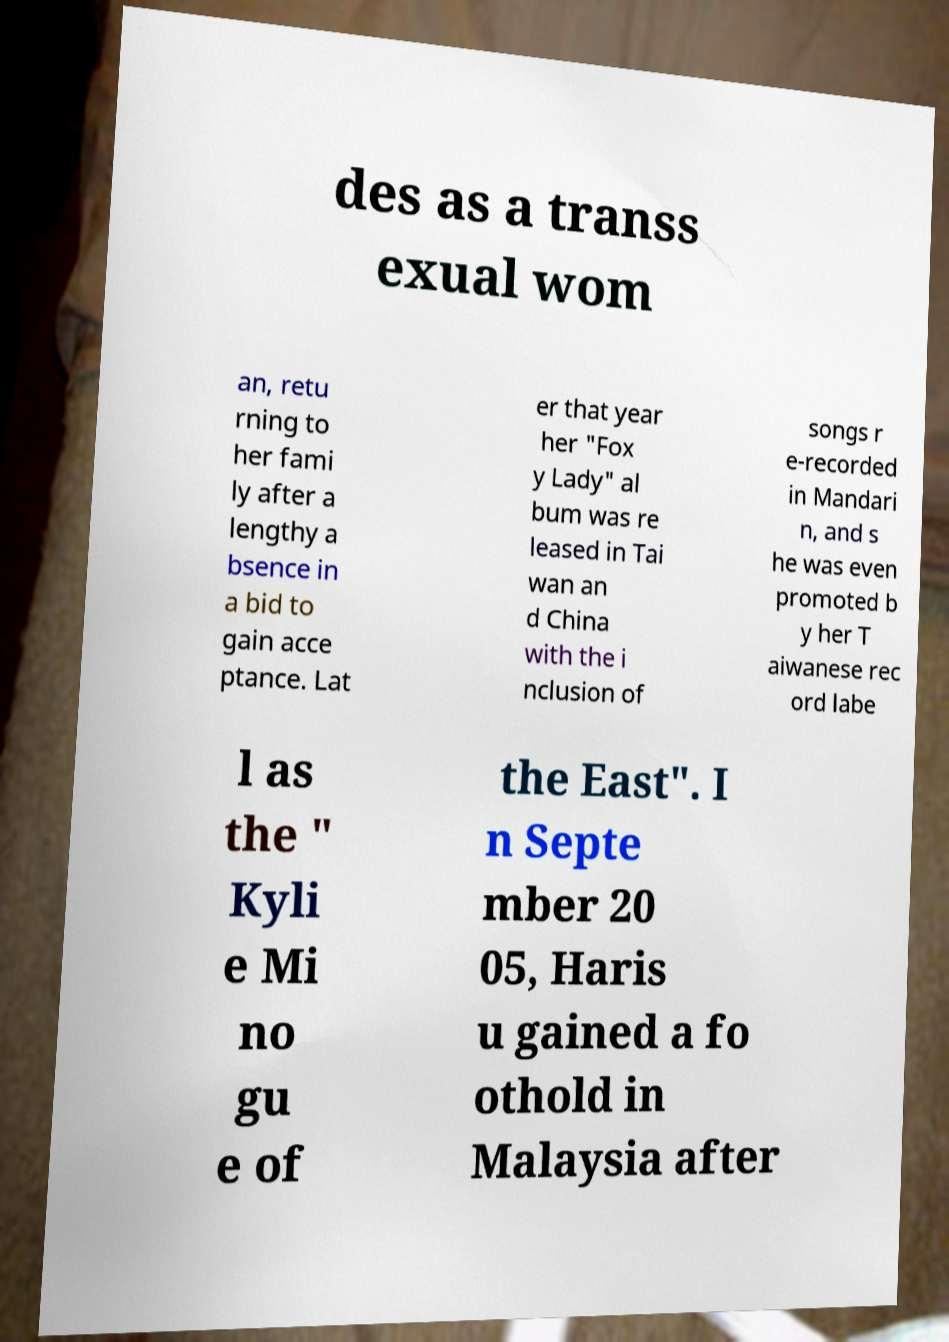For documentation purposes, I need the text within this image transcribed. Could you provide that? des as a transs exual wom an, retu rning to her fami ly after a lengthy a bsence in a bid to gain acce ptance. Lat er that year her "Fox y Lady" al bum was re leased in Tai wan an d China with the i nclusion of songs r e-recorded in Mandari n, and s he was even promoted b y her T aiwanese rec ord labe l as the " Kyli e Mi no gu e of the East". I n Septe mber 20 05, Haris u gained a fo othold in Malaysia after 